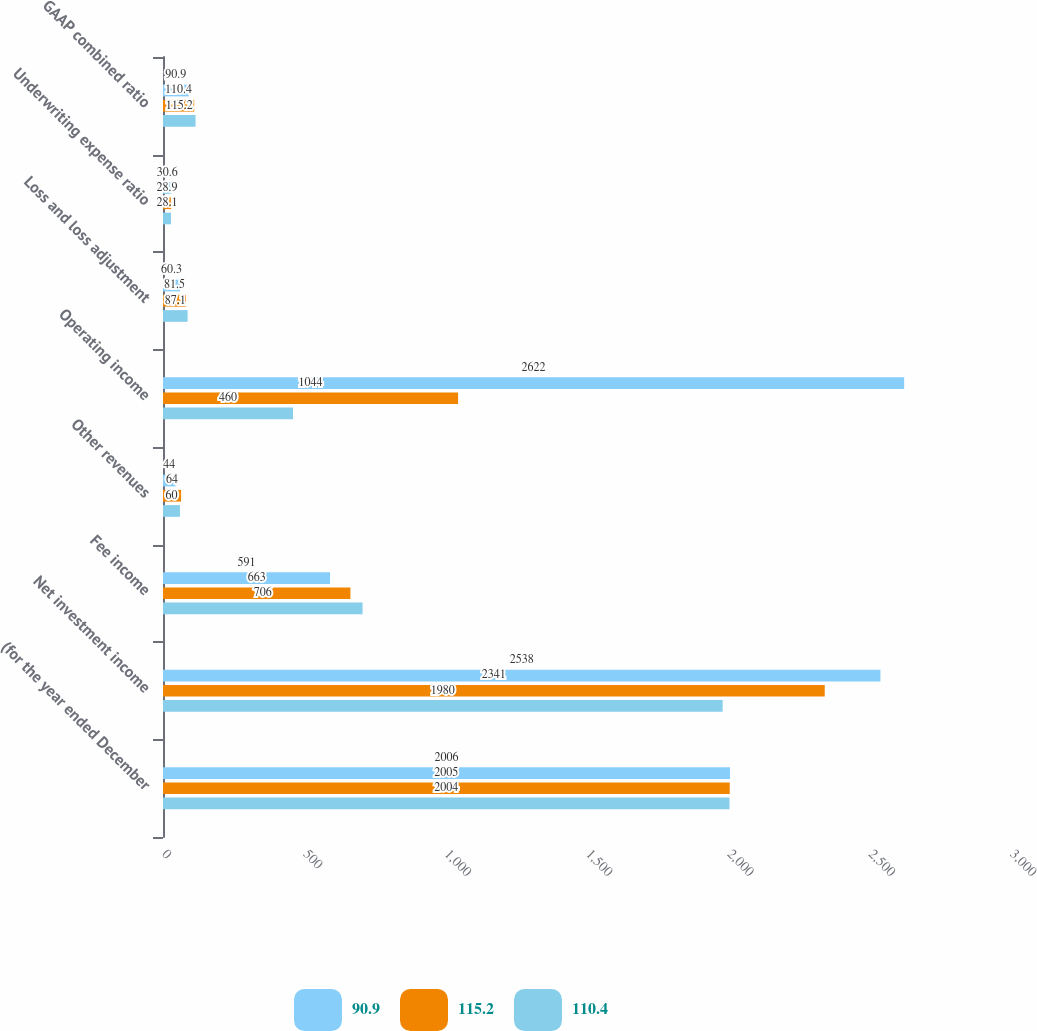<chart> <loc_0><loc_0><loc_500><loc_500><stacked_bar_chart><ecel><fcel>(for the year ended December<fcel>Net investment income<fcel>Fee income<fcel>Other revenues<fcel>Operating income<fcel>Loss and loss adjustment<fcel>Underwriting expense ratio<fcel>GAAP combined ratio<nl><fcel>90.9<fcel>2006<fcel>2538<fcel>591<fcel>44<fcel>2622<fcel>60.3<fcel>30.6<fcel>90.9<nl><fcel>115.2<fcel>2005<fcel>2341<fcel>663<fcel>64<fcel>1044<fcel>81.5<fcel>28.9<fcel>110.4<nl><fcel>110.4<fcel>2004<fcel>1980<fcel>706<fcel>60<fcel>460<fcel>87.1<fcel>28.1<fcel>115.2<nl></chart> 